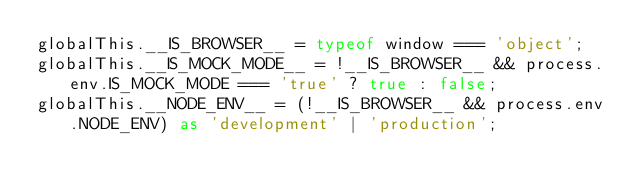Convert code to text. <code><loc_0><loc_0><loc_500><loc_500><_TypeScript_>globalThis.__IS_BROWSER__ = typeof window === 'object';
globalThis.__IS_MOCK_MODE__ = !__IS_BROWSER__ && process.env.IS_MOCK_MODE === 'true' ? true : false;
globalThis.__NODE_ENV__ = (!__IS_BROWSER__ && process.env.NODE_ENV) as 'development' | 'production';
</code> 